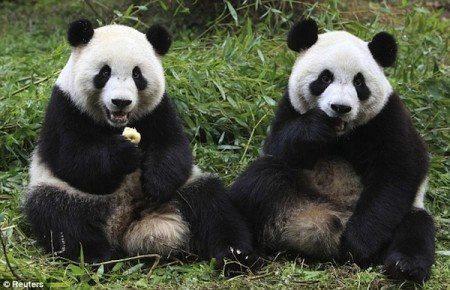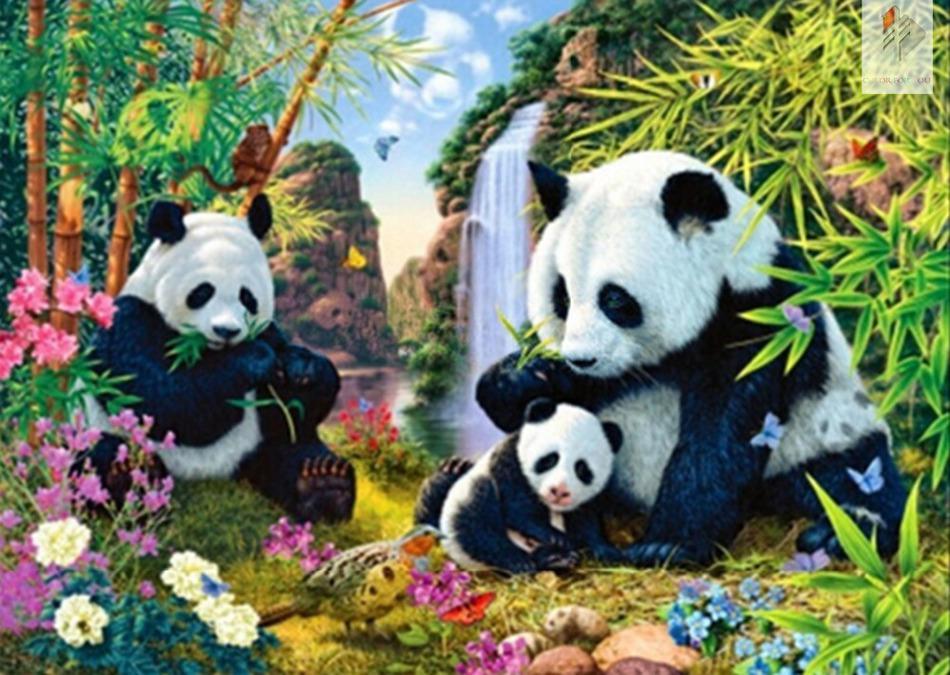The first image is the image on the left, the second image is the image on the right. Considering the images on both sides, is "Each image contains exactly three panda bears." valid? Answer yes or no. No. The first image is the image on the left, the second image is the image on the right. Assess this claim about the two images: "Three pandas are grouped together on the ground in the image on the left.". Correct or not? Answer yes or no. No. 